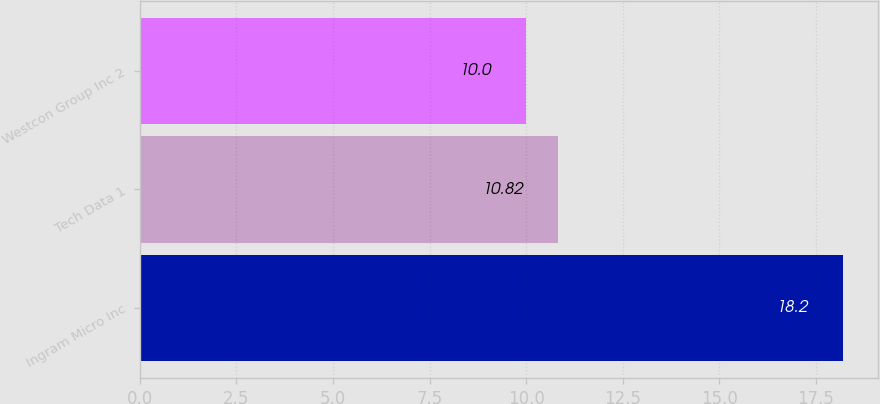Convert chart to OTSL. <chart><loc_0><loc_0><loc_500><loc_500><bar_chart><fcel>Ingram Micro Inc<fcel>Tech Data 1<fcel>Westcon Group Inc 2<nl><fcel>18.2<fcel>10.82<fcel>10<nl></chart> 